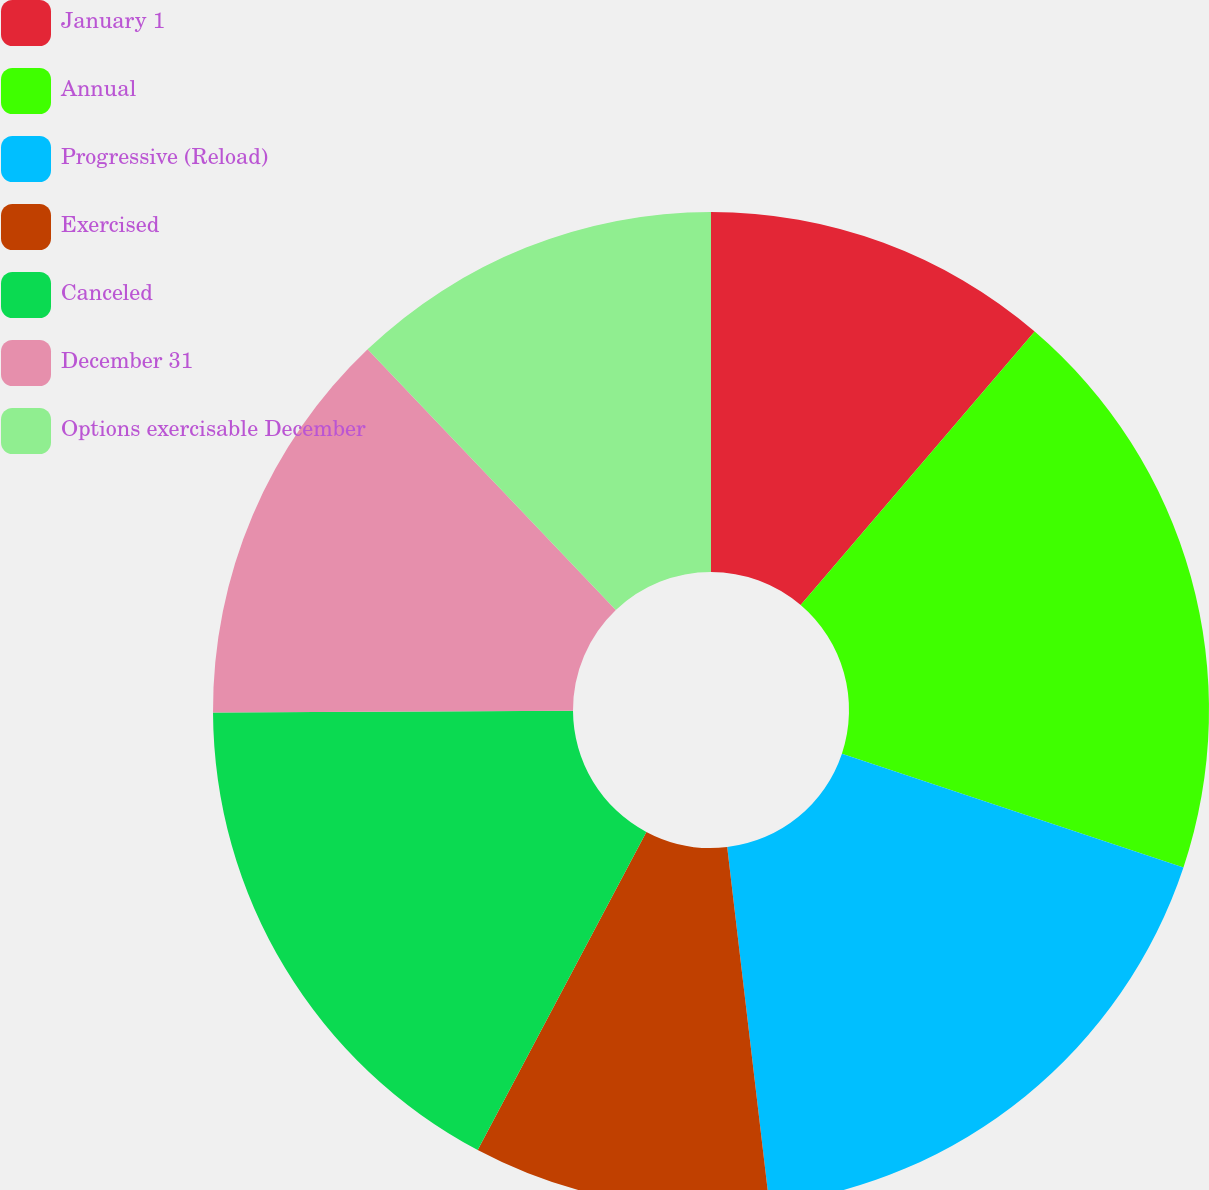Convert chart to OTSL. <chart><loc_0><loc_0><loc_500><loc_500><pie_chart><fcel>January 1<fcel>Annual<fcel>Progressive (Reload)<fcel>Exercised<fcel>Canceled<fcel>December 31<fcel>Options exercisable December<nl><fcel>11.26%<fcel>18.86%<fcel>18.01%<fcel>9.63%<fcel>17.16%<fcel>12.97%<fcel>12.11%<nl></chart> 